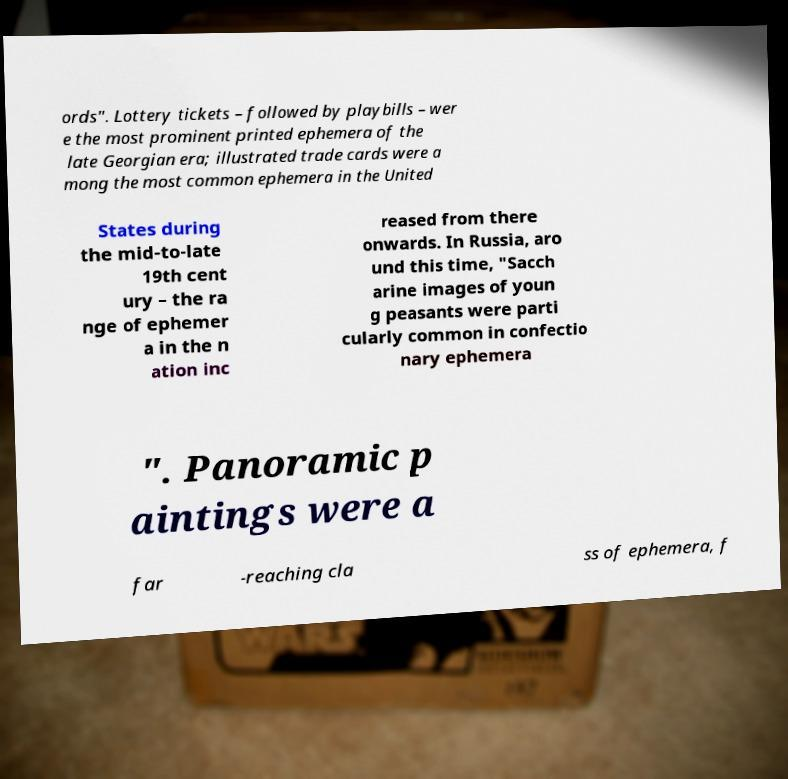Can you read and provide the text displayed in the image?This photo seems to have some interesting text. Can you extract and type it out for me? ords". Lottery tickets – followed by playbills – wer e the most prominent printed ephemera of the late Georgian era; illustrated trade cards were a mong the most common ephemera in the United States during the mid-to-late 19th cent ury – the ra nge of ephemer a in the n ation inc reased from there onwards. In Russia, aro und this time, "Sacch arine images of youn g peasants were parti cularly common in confectio nary ephemera ". Panoramic p aintings were a far -reaching cla ss of ephemera, f 